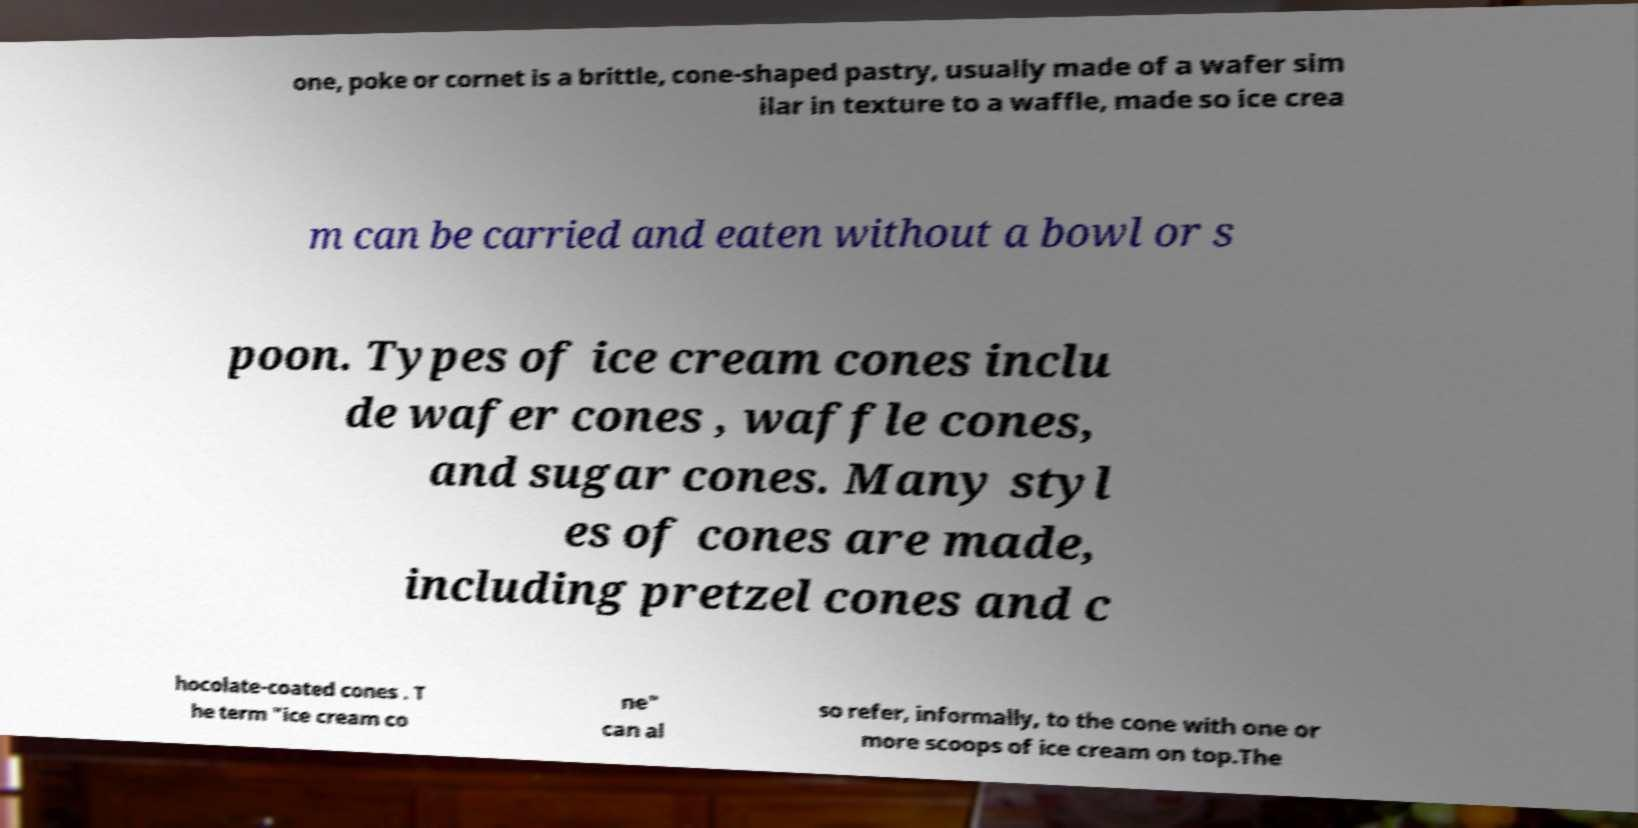I need the written content from this picture converted into text. Can you do that? one, poke or cornet is a brittle, cone-shaped pastry, usually made of a wafer sim ilar in texture to a waffle, made so ice crea m can be carried and eaten without a bowl or s poon. Types of ice cream cones inclu de wafer cones , waffle cones, and sugar cones. Many styl es of cones are made, including pretzel cones and c hocolate-coated cones . T he term "ice cream co ne" can al so refer, informally, to the cone with one or more scoops of ice cream on top.The 